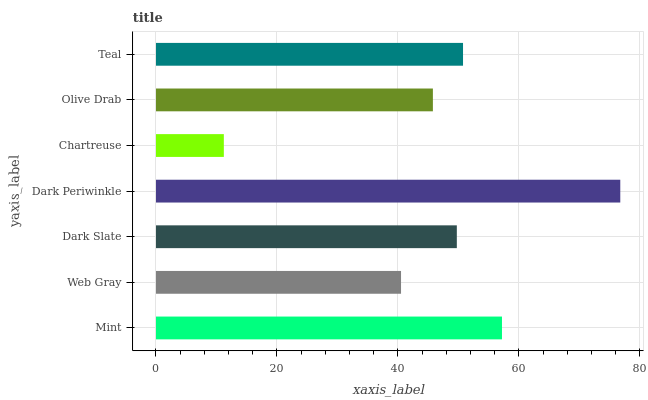Is Chartreuse the minimum?
Answer yes or no. Yes. Is Dark Periwinkle the maximum?
Answer yes or no. Yes. Is Web Gray the minimum?
Answer yes or no. No. Is Web Gray the maximum?
Answer yes or no. No. Is Mint greater than Web Gray?
Answer yes or no. Yes. Is Web Gray less than Mint?
Answer yes or no. Yes. Is Web Gray greater than Mint?
Answer yes or no. No. Is Mint less than Web Gray?
Answer yes or no. No. Is Dark Slate the high median?
Answer yes or no. Yes. Is Dark Slate the low median?
Answer yes or no. Yes. Is Chartreuse the high median?
Answer yes or no. No. Is Dark Periwinkle the low median?
Answer yes or no. No. 